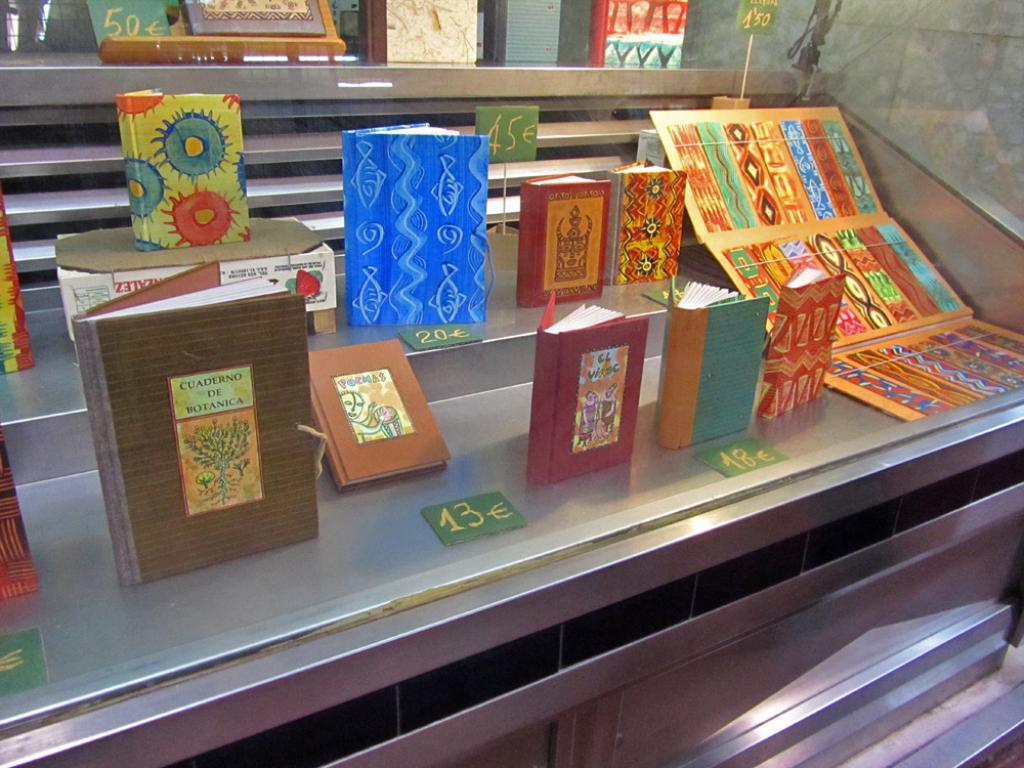What objects are on a stand in the image? There are books on a stand in the image. What type of object has a design on it in the image? There is a cardboard with a design in the image. What can be seen written on a paper in the image? There are numbers written on a paper in the image. What type of metal can be heard making a sound in the image? There is no metal or sound present in the image. How does the care for the objects in the image differ from the care for living organisms? The image does not show any living organisms, so it is not possible to compare the care for objects and living organisms in this context. 